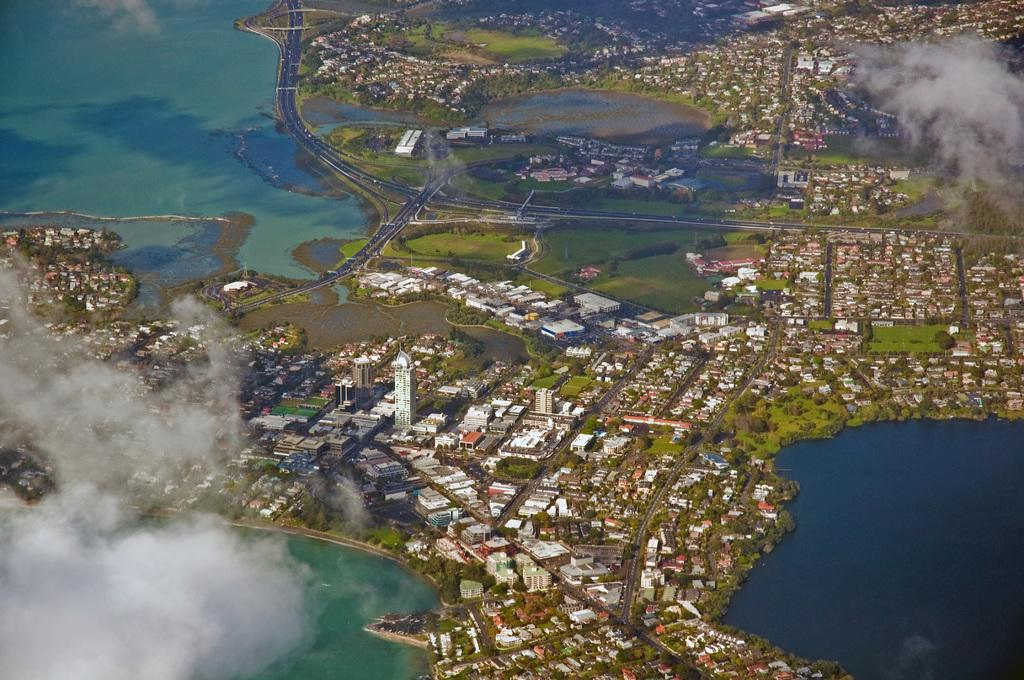What type of view is depicted in the image? The image is an aerial view. What structures can be seen in the image? There are buildings in the image. What type of vegetation is present in the image? There are trees and grass in the image. What type of transportation infrastructure is visible in the image? There are roads in the image. What natural feature can be seen in the image? There is water visible in the image. What can be seen in the sky in the image? There are clouds in the image. Where is the scarecrow located in the image? There is no scarecrow present in the image. What type of mountain can be seen in the image? There is no mountain visible in the image. 